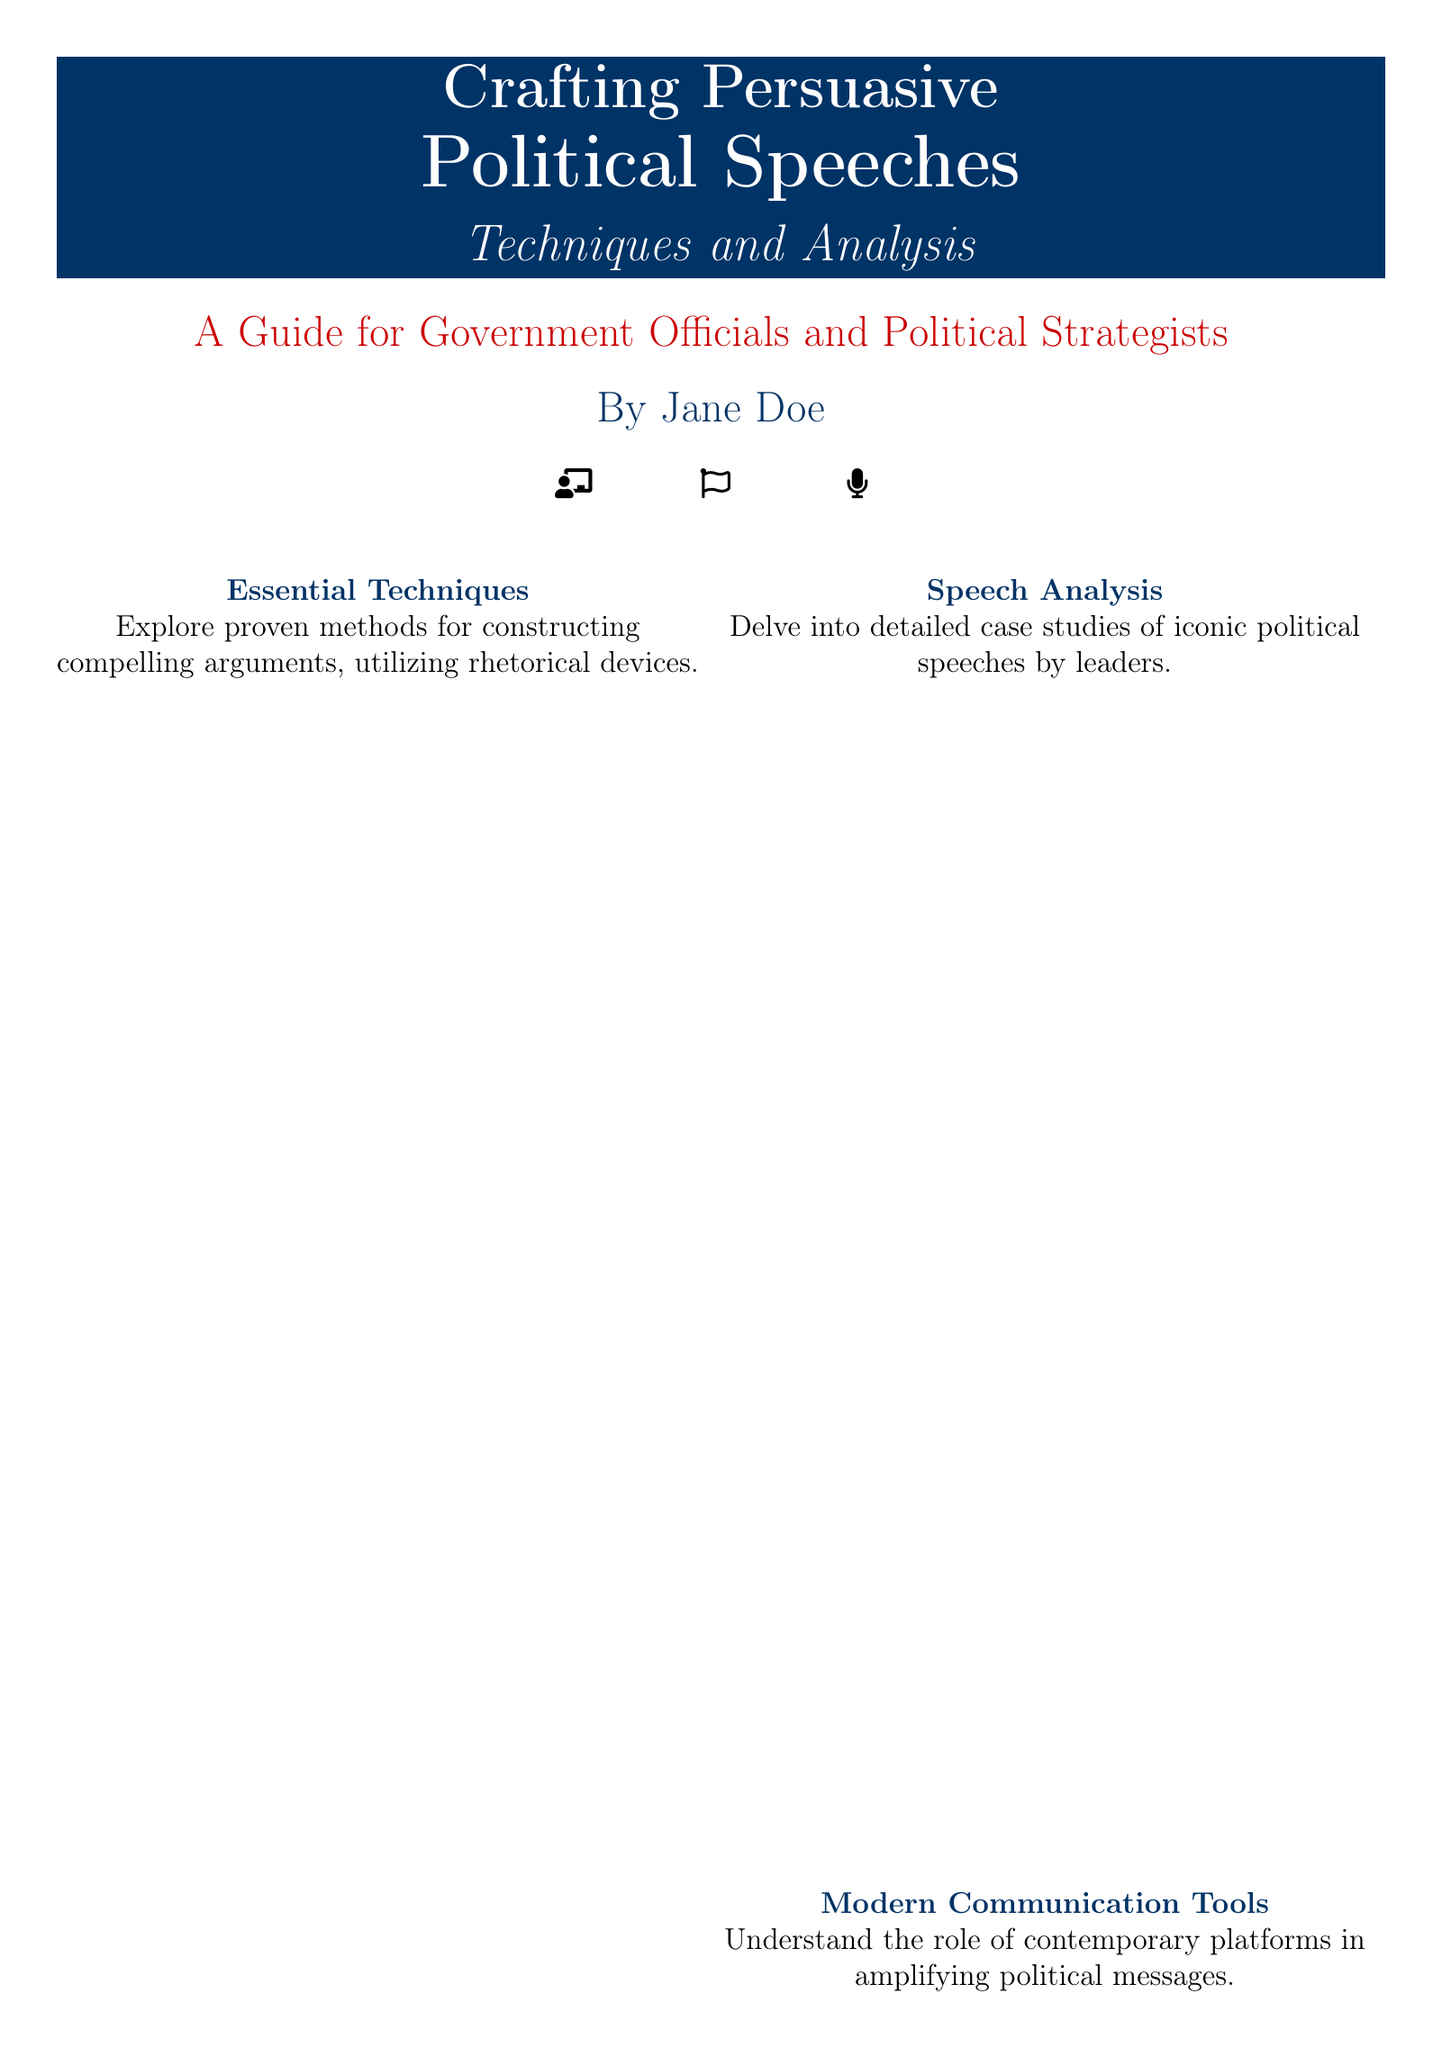What is the title of the book? The title is prominently displayed on the cover of the book, indicating its focus and subject matter.
Answer: Crafting Persuasive Political Speeches Who is the author of the book? The author's name is displayed clearly on the cover, positioned under the title.
Answer: Jane Doe What year was the book published? The publication year is noted at the bottom of the cover page.
Answer: 2023 What is the subtitle of the book? The subtitle provides additional context on the book's content and is found directly below the title.
Answer: Techniques and Analysis What is the primary audience for the book? The cover specifically mentions the target readers in the description section.
Answer: Government Officials and Political Strategists What color scheme is primarily used on the book cover? The colors used in the cover design are consistent and primarily reflect a professional appearance.
Answer: Deep blue and vibrant red Which elements are represented by icons on the cover? The icons visually depict themes relevant to the book's content, specifically targeting political communication.
Answer: Flag, microphone, podium What is the main theme of the essential techniques section? This section outlines the key focus area of the book content regarding persuasive speech crafting.
Answer: Compelling arguments and rhetorical devices Who recommended the book according to the cover? A notable figure's endorsement adds credibility to the book's content, quoted on the cover.
Answer: John Smith, Senior Advisor to the President 